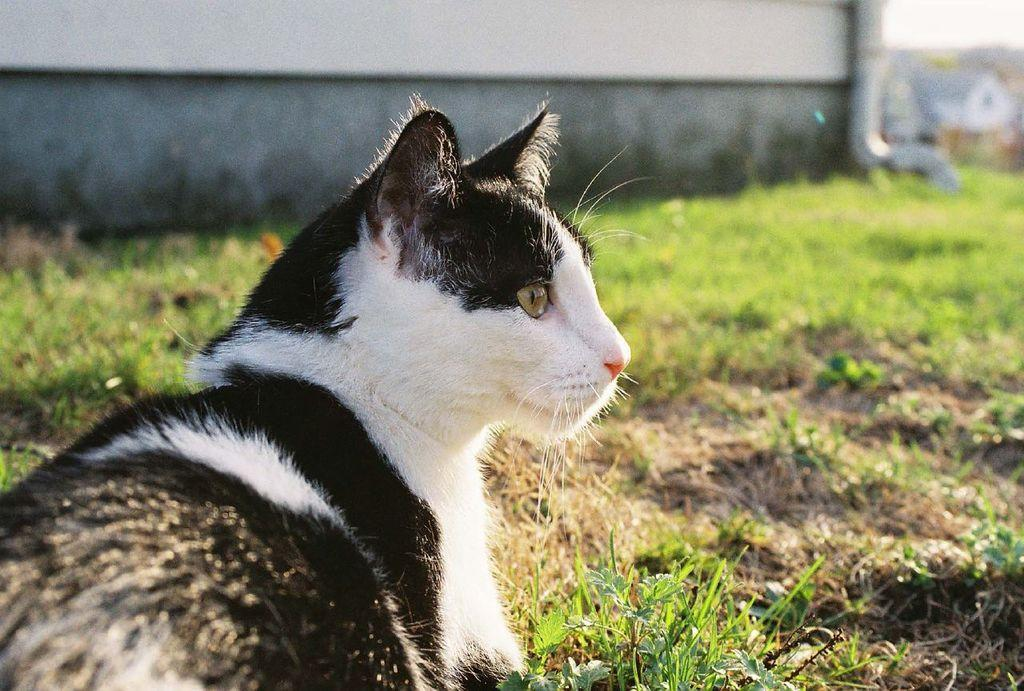What animal is present in the image? There is a cat in the image. Where is the cat located? The cat is on the grass. What is behind the cat? There is a wall behind the cat. Can you describe the top right corner of the image? There appears to be a house in the top right corner of the image. How many eyes does the lumber have in the image? There is no lumber present in the image, and therefore no eyes to count. 